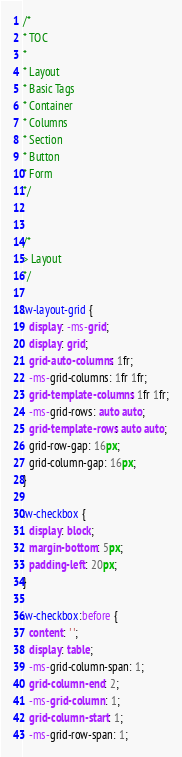Convert code to text. <code><loc_0><loc_0><loc_500><loc_500><_CSS_>/*
* TOC
*
* Layout
* Basic Tags
* Container
* Columns
* Section
* Button
* Form
*/


/*
> Layout
*/

.w-layout-grid {
  display: -ms-grid;
  display: grid;
  grid-auto-columns: 1fr;
  -ms-grid-columns: 1fr 1fr;
  grid-template-columns: 1fr 1fr;
  -ms-grid-rows: auto auto;
  grid-template-rows: auto auto;
  grid-row-gap: 16px;
  grid-column-gap: 16px;
}

.w-checkbox {
  display: block;
  margin-bottom: 5px;
  padding-left: 20px;
}

.w-checkbox:before {
  content: ' ';
  display: table;
  -ms-grid-column-span: 1;
  grid-column-end: 2;
  -ms-grid-column: 1;
  grid-column-start: 1;
  -ms-grid-row-span: 1;</code> 